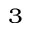Convert formula to latex. <formula><loc_0><loc_0><loc_500><loc_500>^ { 3 }</formula> 